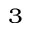Convert formula to latex. <formula><loc_0><loc_0><loc_500><loc_500>^ { 3 }</formula> 